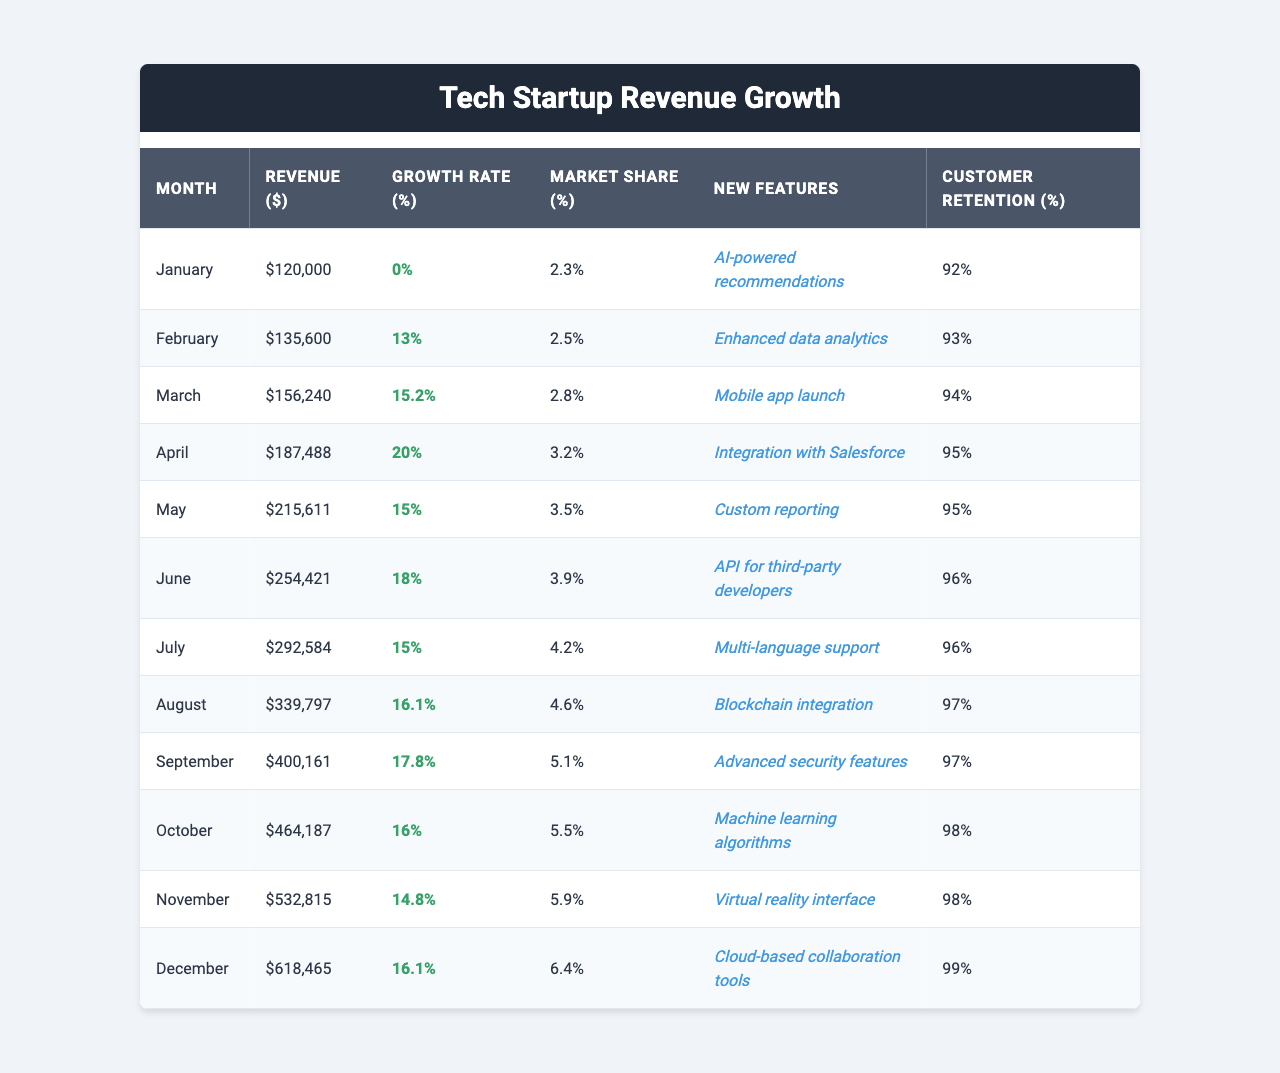What was the total revenue in December? The table shows that the revenue in December was $618,465.
Answer: $618,465 What is the highest growth rate achieved in the year? By examining the Growth Rate column, the highest value is 20% in April.
Answer: 20% Which month had the lowest customer retention percentage? Looking at the Customer Retention column, January had the lowest retention at 92%.
Answer: 92% What was the average revenue growth rate for the year? To calculate the average growth rate, sum all monthly growth rates: (0 + 13 + 15.2 + 20 + 15 + 18 + 15 + 16.1 + 17.8 + 16 + 14.8 + 16.1) =  18.92, and divide by 12, resulting in approximately 15.76%.
Answer: 15.76% Did the revenue growth rate increase every month? By reviewing the Growth Rate column, there is a decrease from November to December (14.8% to 16.1%), indicating a not consistent increase.
Answer: No What was the percent increase in revenue from January to April? The revenue in January was $120,000 and in April it was $187,488. The increase is calculated as: (187488 - 120000) / 120000 * 100 = 56.24%.
Answer: 56.24% How many new features were launched in the second half of the year? The table lists new features for July to December, which accounts for 6 months. Each month has different new features noted, adding up to 6 new features in total.
Answer: 6 Which month had the highest market share? Scanning the Market Share column, December has the highest value at 6.4%.
Answer: 6.4% What is the difference in revenue between the highest and lowest months? December had the highest revenue of $618,465, while January had the lowest at $120,000. The difference is $618,465 - $120,000 = $498,465.
Answer: $498,465 Was the growth rate in August higher than in June? August has a growth rate of 16.1%, while June has 18%. Therefore, August did not exceed June's growth rate.
Answer: No 